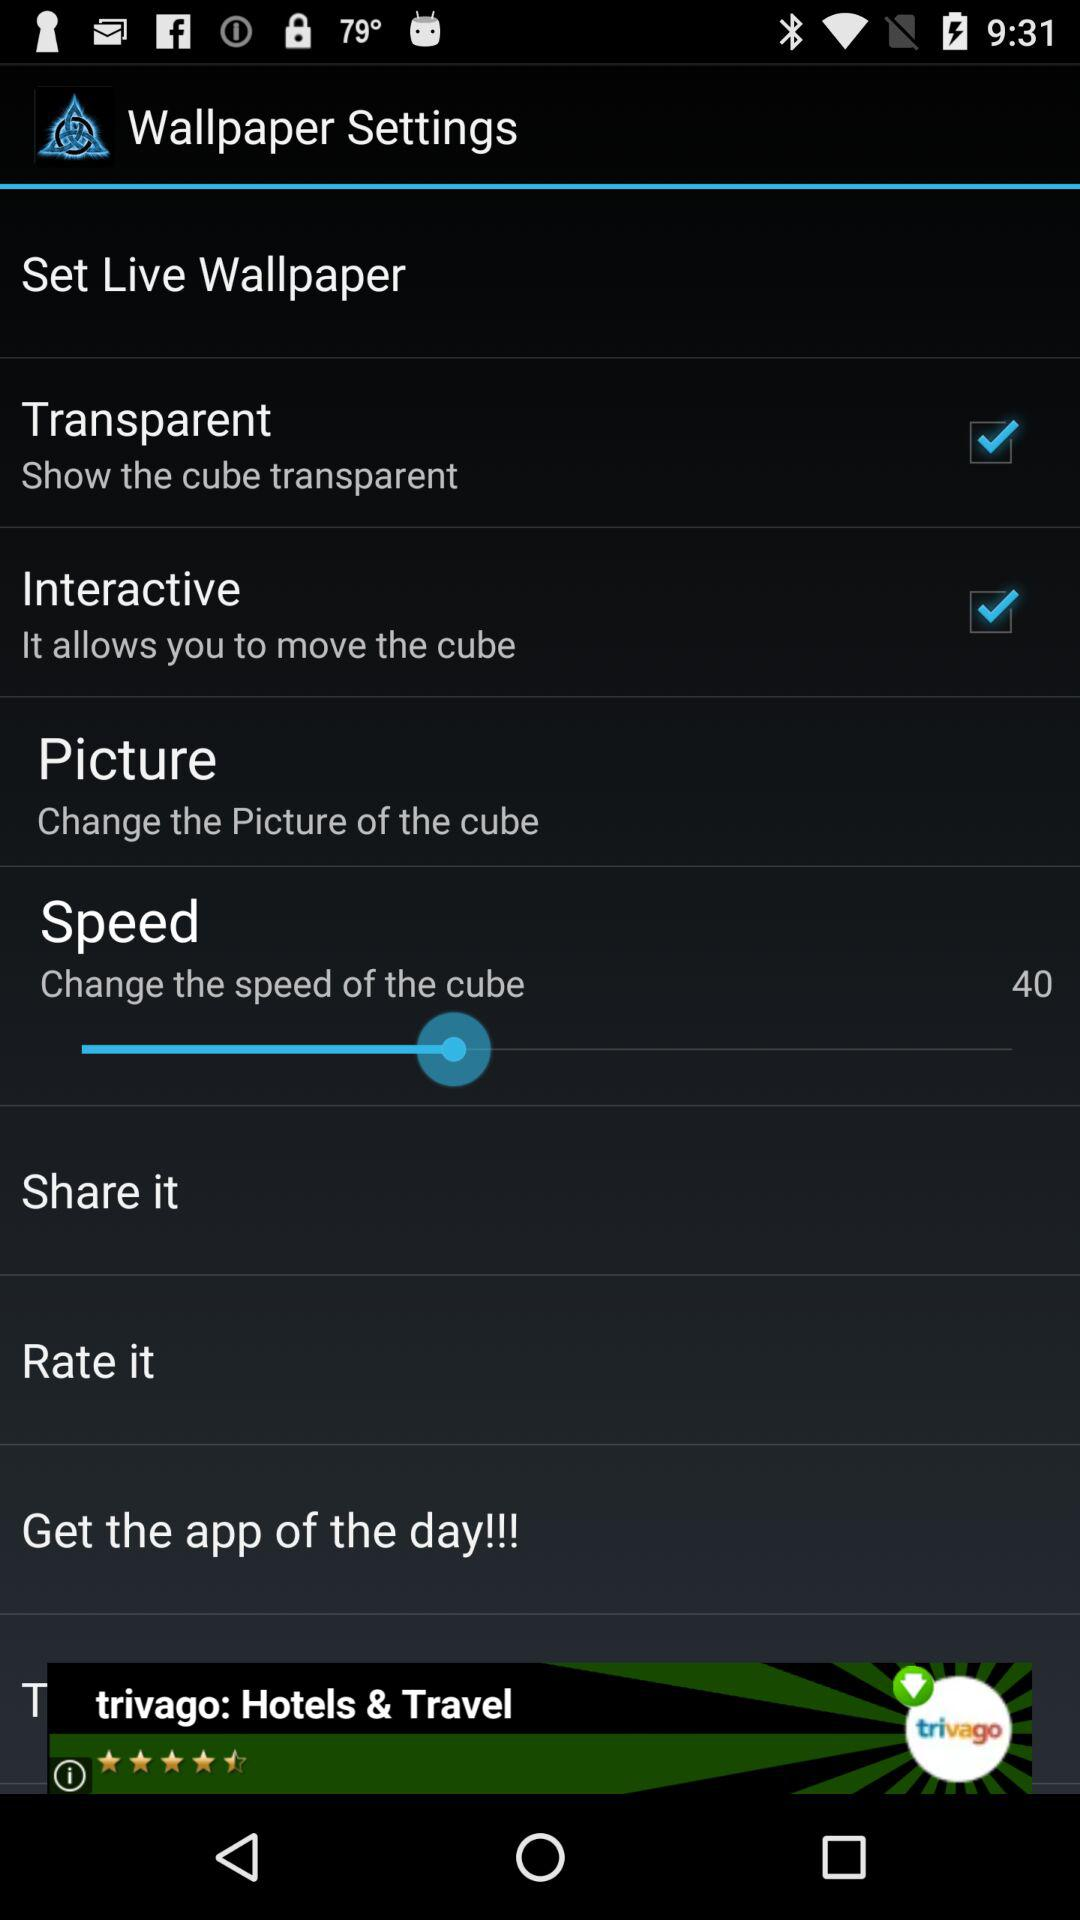What is the status of "Transparent"? The status is "on". 